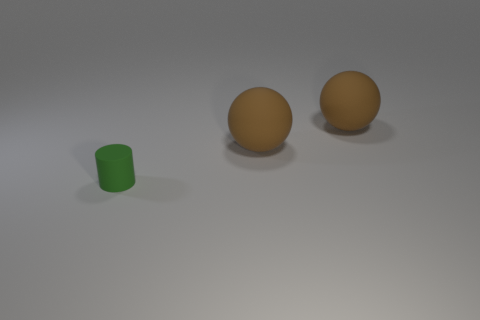Add 3 brown balls. How many objects exist? 6 Subtract all cylinders. How many objects are left? 2 Subtract all big cyan balls. Subtract all green matte things. How many objects are left? 2 Add 1 spheres. How many spheres are left? 3 Add 2 green matte objects. How many green matte objects exist? 3 Subtract 0 green blocks. How many objects are left? 3 